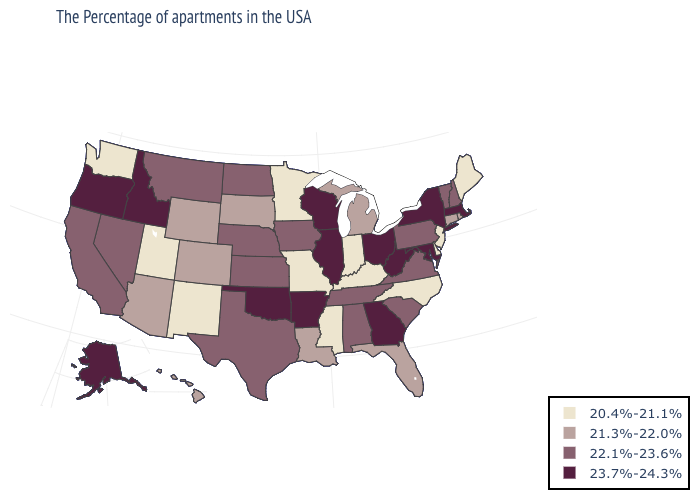Does Montana have a higher value than Georgia?
Write a very short answer. No. What is the value of North Dakota?
Give a very brief answer. 22.1%-23.6%. What is the lowest value in the USA?
Concise answer only. 20.4%-21.1%. Does the first symbol in the legend represent the smallest category?
Short answer required. Yes. Name the states that have a value in the range 23.7%-24.3%?
Concise answer only. Massachusetts, New York, Maryland, West Virginia, Ohio, Georgia, Wisconsin, Illinois, Arkansas, Oklahoma, Idaho, Oregon, Alaska. What is the value of Kentucky?
Keep it brief. 20.4%-21.1%. Does Georgia have a higher value than North Dakota?
Short answer required. Yes. Which states have the lowest value in the USA?
Be succinct. Maine, New Jersey, Delaware, North Carolina, Kentucky, Indiana, Mississippi, Missouri, Minnesota, New Mexico, Utah, Washington. What is the value of Maryland?
Answer briefly. 23.7%-24.3%. Which states have the lowest value in the USA?
Short answer required. Maine, New Jersey, Delaware, North Carolina, Kentucky, Indiana, Mississippi, Missouri, Minnesota, New Mexico, Utah, Washington. What is the lowest value in states that border Nebraska?
Write a very short answer. 20.4%-21.1%. Which states hav the highest value in the West?
Keep it brief. Idaho, Oregon, Alaska. What is the lowest value in the USA?
Concise answer only. 20.4%-21.1%. Which states have the highest value in the USA?
Write a very short answer. Massachusetts, New York, Maryland, West Virginia, Ohio, Georgia, Wisconsin, Illinois, Arkansas, Oklahoma, Idaho, Oregon, Alaska. Which states hav the highest value in the West?
Concise answer only. Idaho, Oregon, Alaska. 